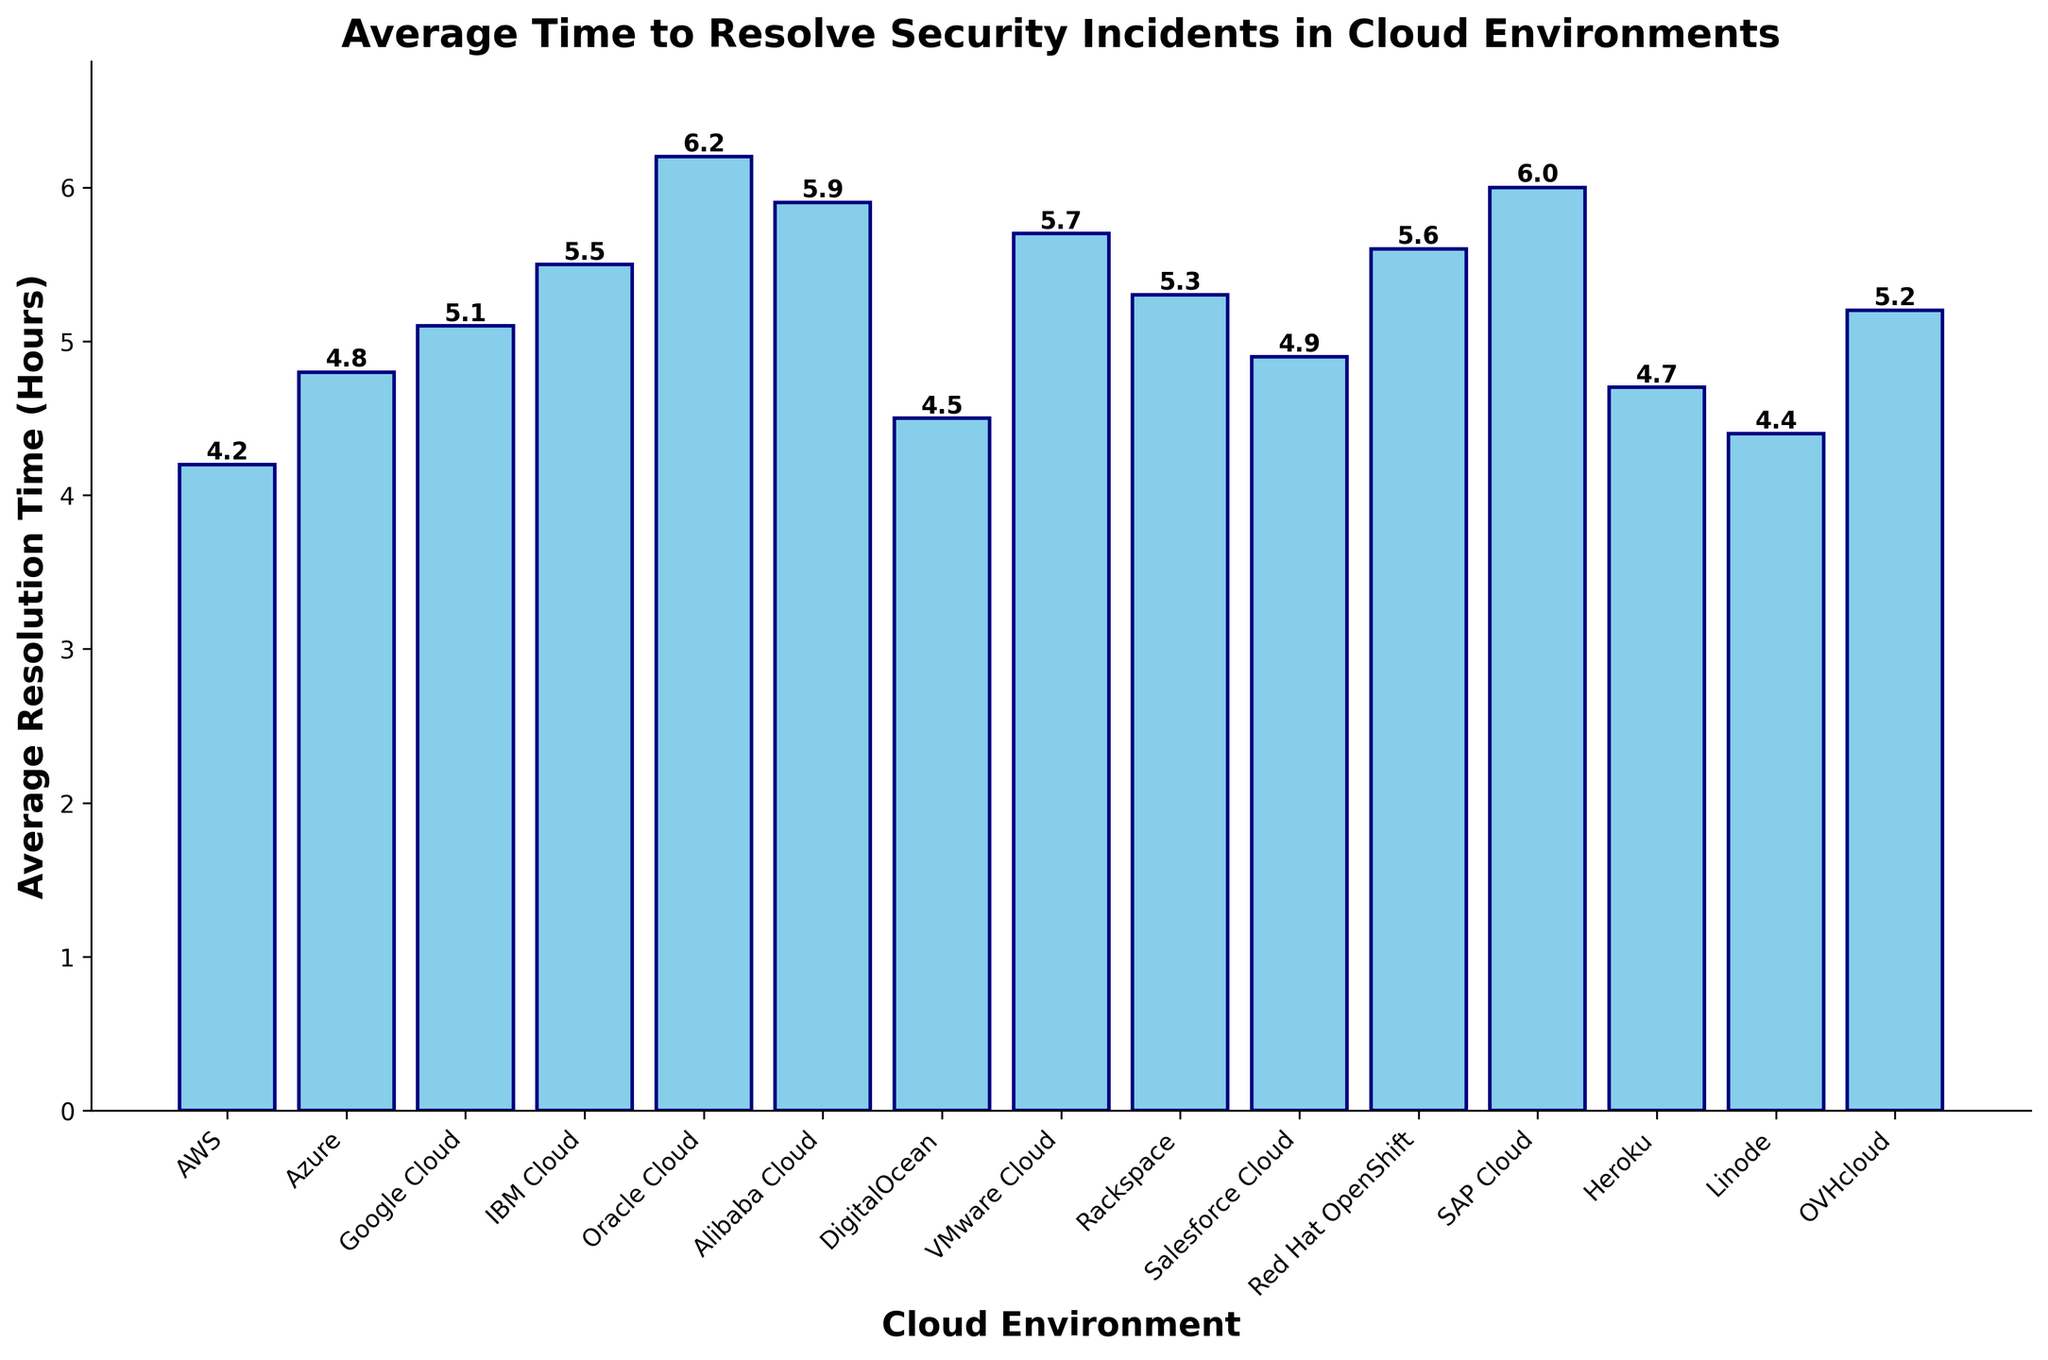Which cloud environment has the shortest average time to resolve security incidents? The bar corresponding to the shortest average time will be the shortest. Identify the bar with the lowest height. In this case, it is AWS.
Answer: AWS Which cloud environment has the longest average time to resolve security incidents, and what is that time? The bar corresponding to the longest average time will be the tallest. Identify the bar with the highest height, which is Oracle Cloud at 6.2 hours.
Answer: Oracle Cloud, 6.2 hours How does Google Cloud's average resolution time compare to DigitalOcean's? Locate the heights of the bars for Google Cloud and DigitalOcean. Google Cloud is at 5.1 hours, and DigitalOcean is at 4.5 hours. Compare these two values.
Answer: Google Cloud is 0.6 hours longer What is the average resolution time for the environments listed in the plot? Sum the average resolution times for all cloud environments and divide by the number of environments. (4.2 + 4.8 + 5.1 + 5.5 + 6.2 + 5.9 + 4.5 + 5.7 + 5.3 + 4.9 + 5.6 + 6.0 + 4.7 + 4.4 + 5.2) / 15 = 5.2
Answer: 5.2 hours Which environments have an average resolution time of under 5 hours? Identify the bars that are below the 5-hour mark. These environments are AWS, DigitalOcean, Salesforce Cloud, Heroku, and Linode.
Answer: AWS, DigitalOcean, Salesforce Cloud, Heroku, Linode How much longer does it take to resolve incidents in IBM Cloud compared to Linode? Identify the heights of the bars for IBM Cloud and Linode. IBM Cloud is at 5.5 hours, and Linode is at 4.4 hours. Calculate the difference.
Answer: 1.1 hours What is the median resolution time of all the cloud environments listed? Arrange the resolution times in ascending order and find the middle value. Ordered times: 4.2, 4.4, 4.5, 4.7, 4.8, 4.9, 5.1, 5.2, 5.3, 5.5, 5.6, 5.7, 5.9, 6.0, 6.2. The median is the 8th value in this ordered list.
Answer: 5.2 hours Which cloud environments have a resolution time exactly equal to the median? From the median calculation, the median value is 5.2. The environment with this value is OVHcloud.
Answer: OVHcloud 